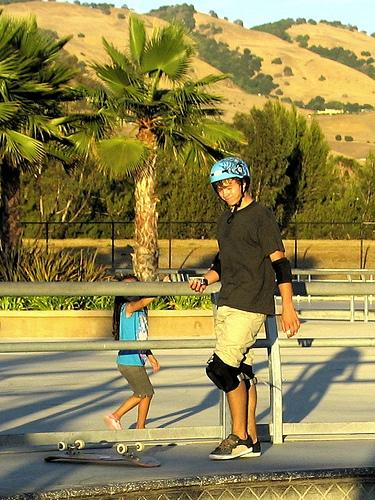What kind of palm tree is in the center of this photo? Please explain your reasoning. fan palm. As indicated by a google search. the fronds fan outward. 